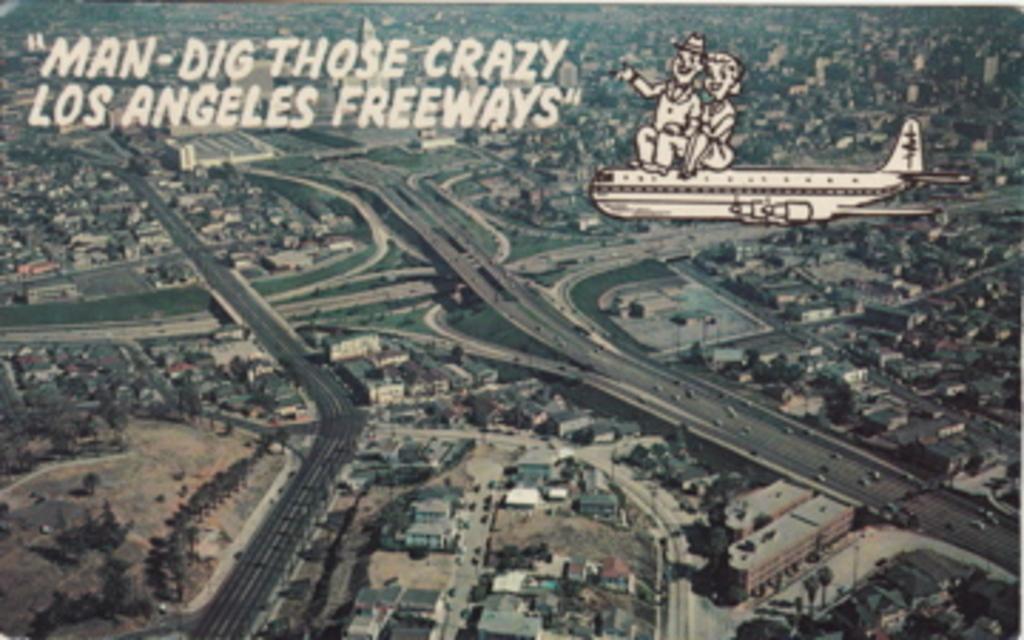Please provide a concise description of this image. In the picture we can see a city from the Ariel view with roads, houses, buildings, trees, grass surfaces and written on it as man dig those crazy Los angels. 